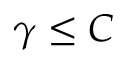<formula> <loc_0><loc_0><loc_500><loc_500>\gamma \leq C</formula> 